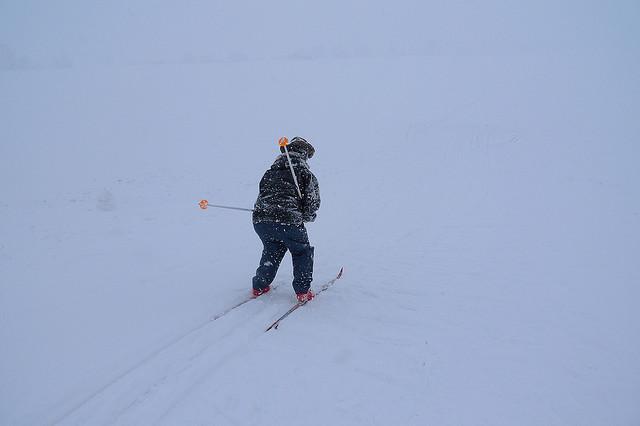Is this person wearing shorts?
Be succinct. No. What is the person doing?
Quick response, please. Skiing. What is the white stuff?
Give a very brief answer. Snow. Is someone taking a picture from behind?
Be succinct. Yes. Is the skier wearing a helmet?
Answer briefly. No. 